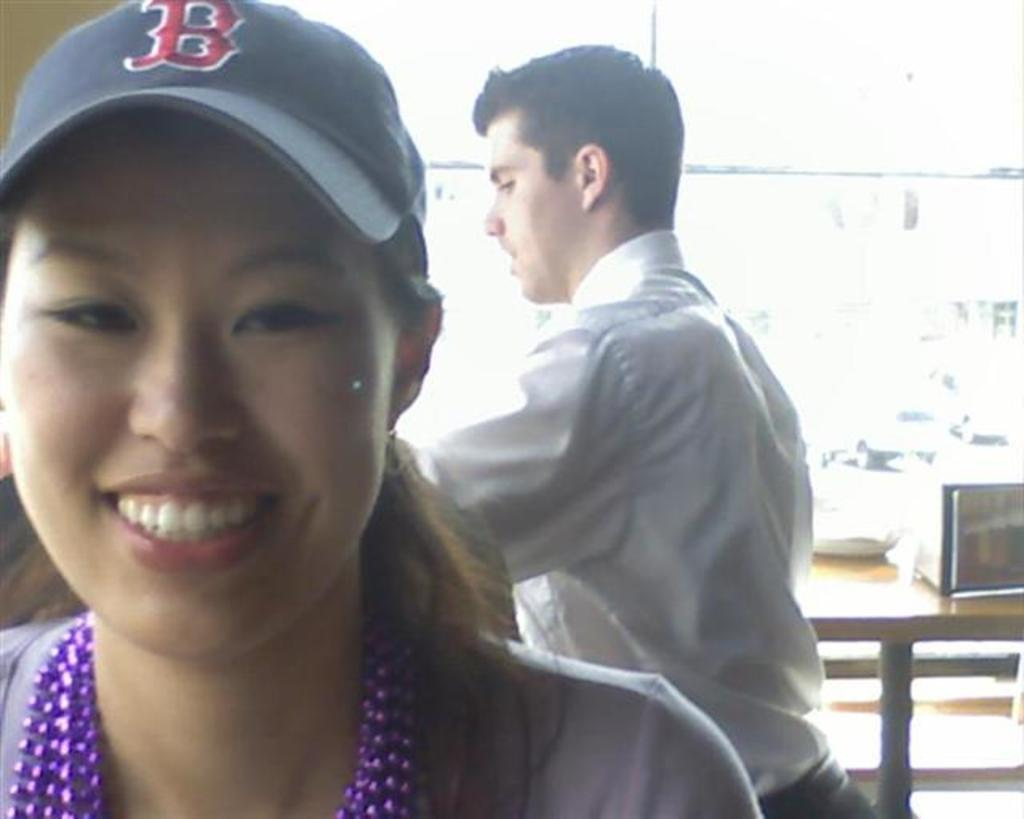<image>
Render a clear and concise summary of the photo. Woman posing for a photo while wearing a letter B on her cap. 